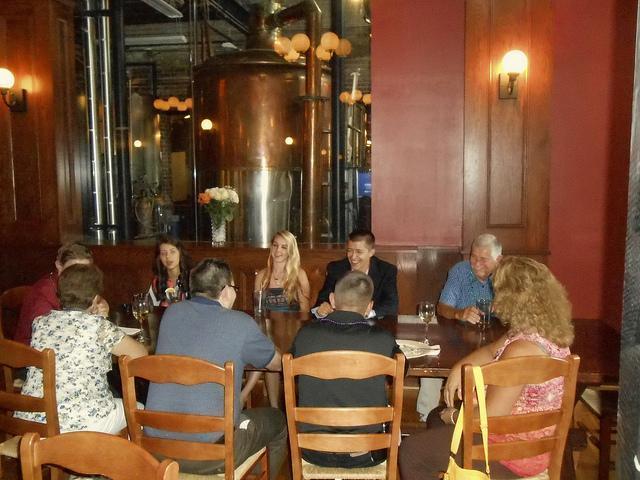How many children do you see?
Give a very brief answer. 0. How many people are sitting down?
Give a very brief answer. 9. How many chairs are in the picture?
Give a very brief answer. 6. How many people are visible?
Give a very brief answer. 9. 